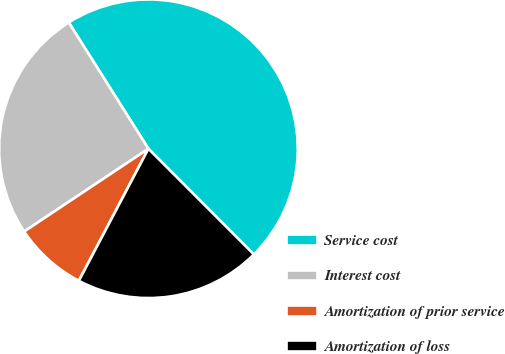<chart> <loc_0><loc_0><loc_500><loc_500><pie_chart><fcel>Service cost<fcel>Interest cost<fcel>Amortization of prior service<fcel>Amortization of loss<nl><fcel>46.47%<fcel>25.4%<fcel>7.93%<fcel>20.2%<nl></chart> 